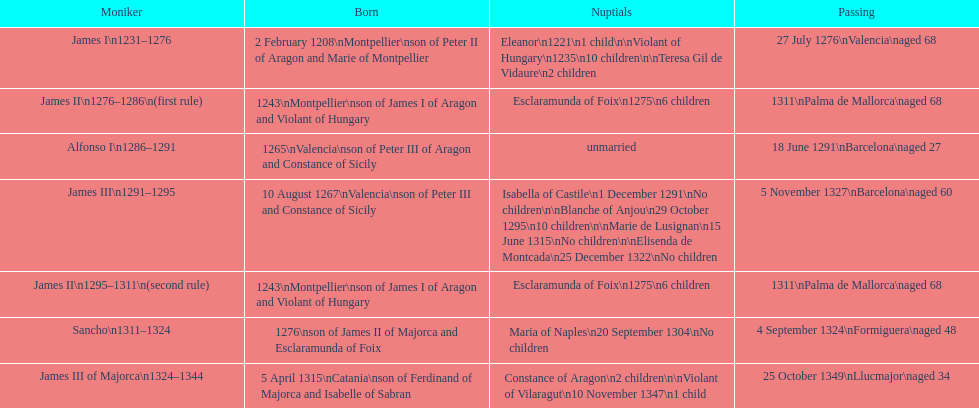Which two monarchs had no children? Alfonso I, Sancho. 